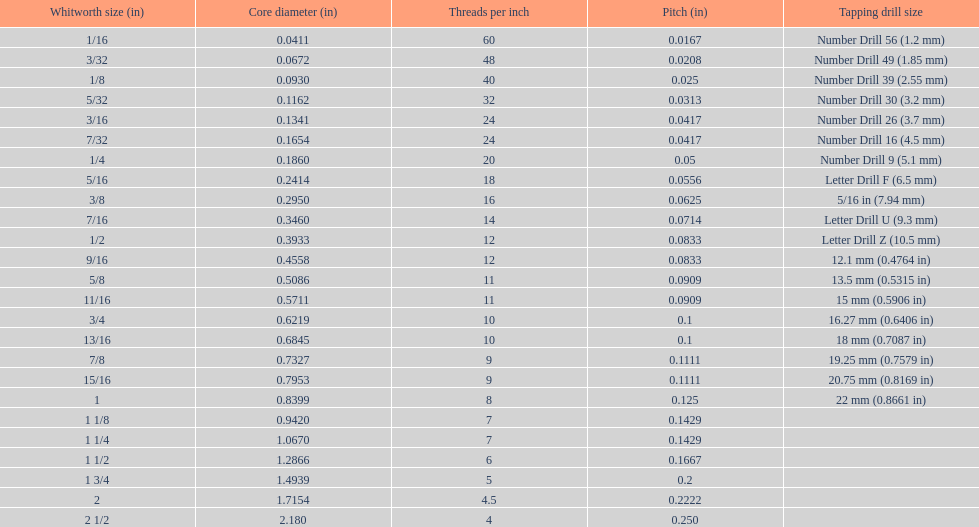What is the core diameter of the first 1/8 whitworth size (in)? 0.0930. 